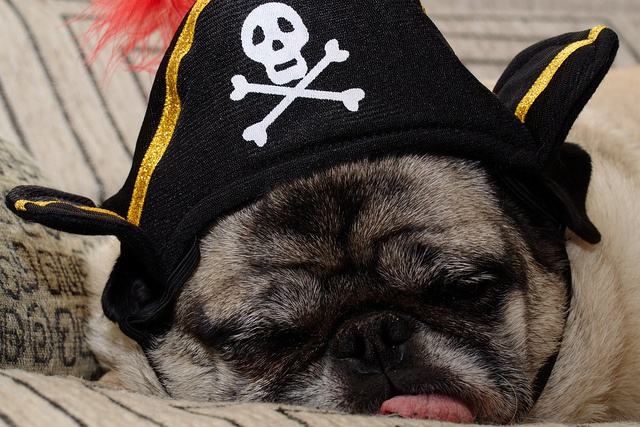Describe the objects in this image and their specific colors. I can see a dog in lightgray, black, gray, and darkgray tones in this image. 